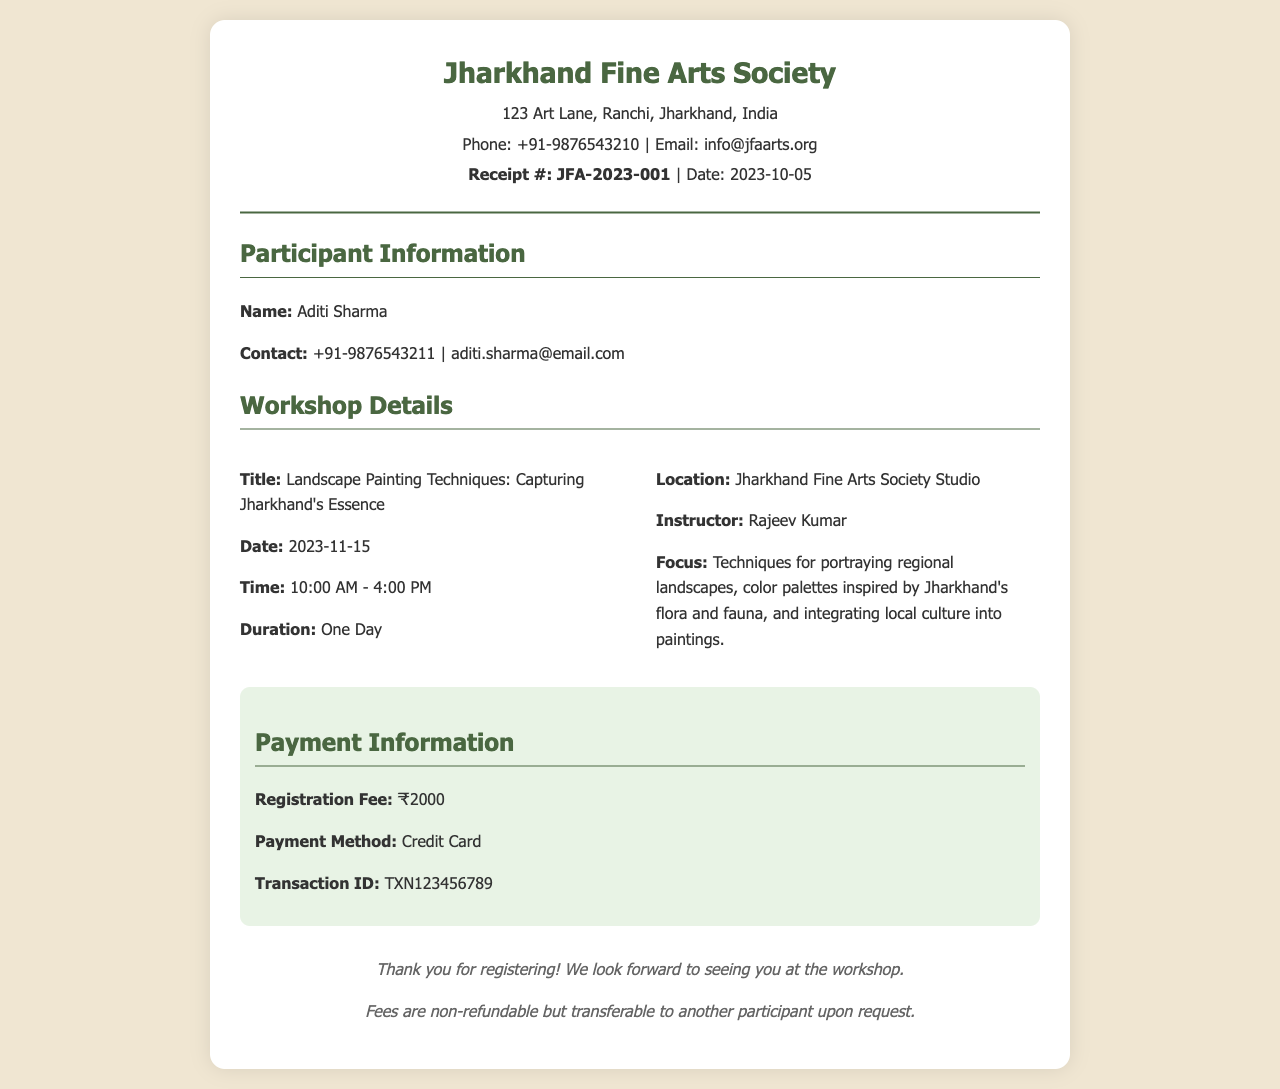what is the name of the society hosting the workshop? The society hosting the workshop is mentioned in the header of the receipt.
Answer: Jharkhand Fine Arts Society what is the registration fee for the workshop? The registration fee is given in the payment section of the document.
Answer: ₹2000 who is the instructor for the workshop? The instructor's name is provided in the workshop details section.
Answer: Rajeev Kumar when is the workshop scheduled to take place? The date of the workshop is clearly stated in the workshop details.
Answer: 2023-11-15 what is the duration of the workshop? The duration is specified in the workshop details section.
Answer: One Day what payment method was used for registration? The payment method is noted in the payment information section.
Answer: Credit Card what is the contact email of the participant? The contact email is included in the participant information section.
Answer: aditi.sharma@email.com what is the focus of the workshop? The focus of the workshop is outlined in the details provided about the instructor and the workshop.
Answer: Techniques for portraying regional landscapes who is the recipient of this receipt? The participant's name is indicated in the participant information section.
Answer: Aditi Sharma what is the transaction ID for the payment? The transaction ID is found in the payment information section.
Answer: TXN123456789 